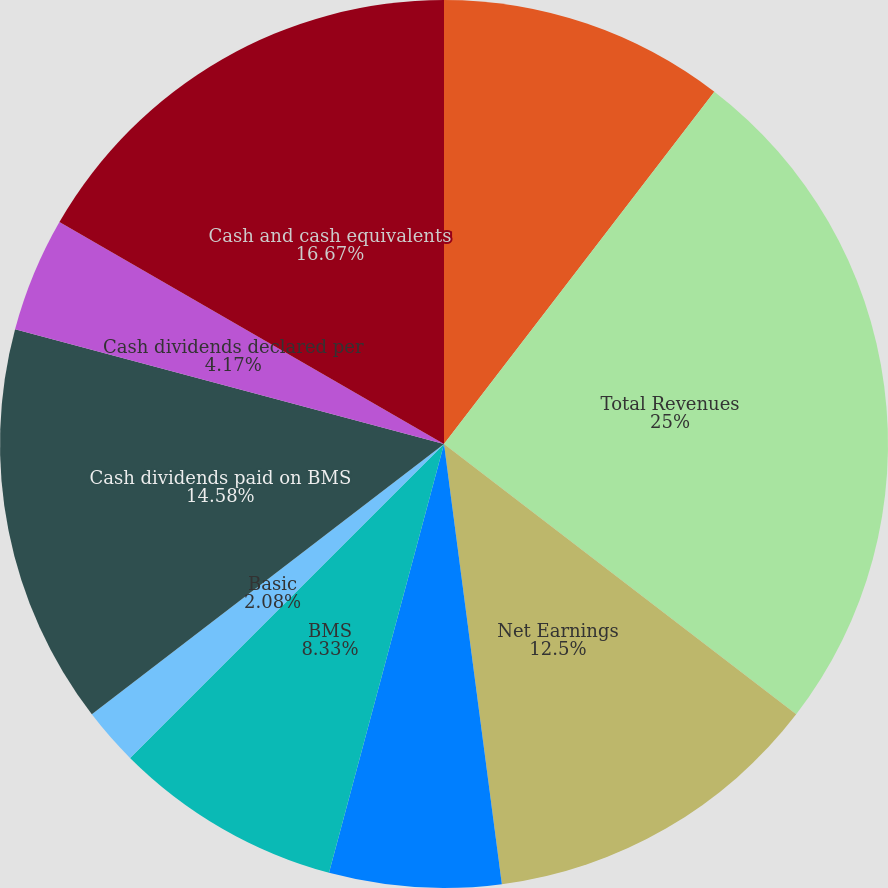Convert chart to OTSL. <chart><loc_0><loc_0><loc_500><loc_500><pie_chart><fcel>Amounts in Millions except per<fcel>Total Revenues<fcel>Net Earnings<fcel>Noncontrolling Interest<fcel>BMS<fcel>Basic<fcel>Diluted<fcel>Cash dividends paid on BMS<fcel>Cash dividends declared per<fcel>Cash and cash equivalents<nl><fcel>10.42%<fcel>25.0%<fcel>12.5%<fcel>6.25%<fcel>8.33%<fcel>2.08%<fcel>0.0%<fcel>14.58%<fcel>4.17%<fcel>16.67%<nl></chart> 